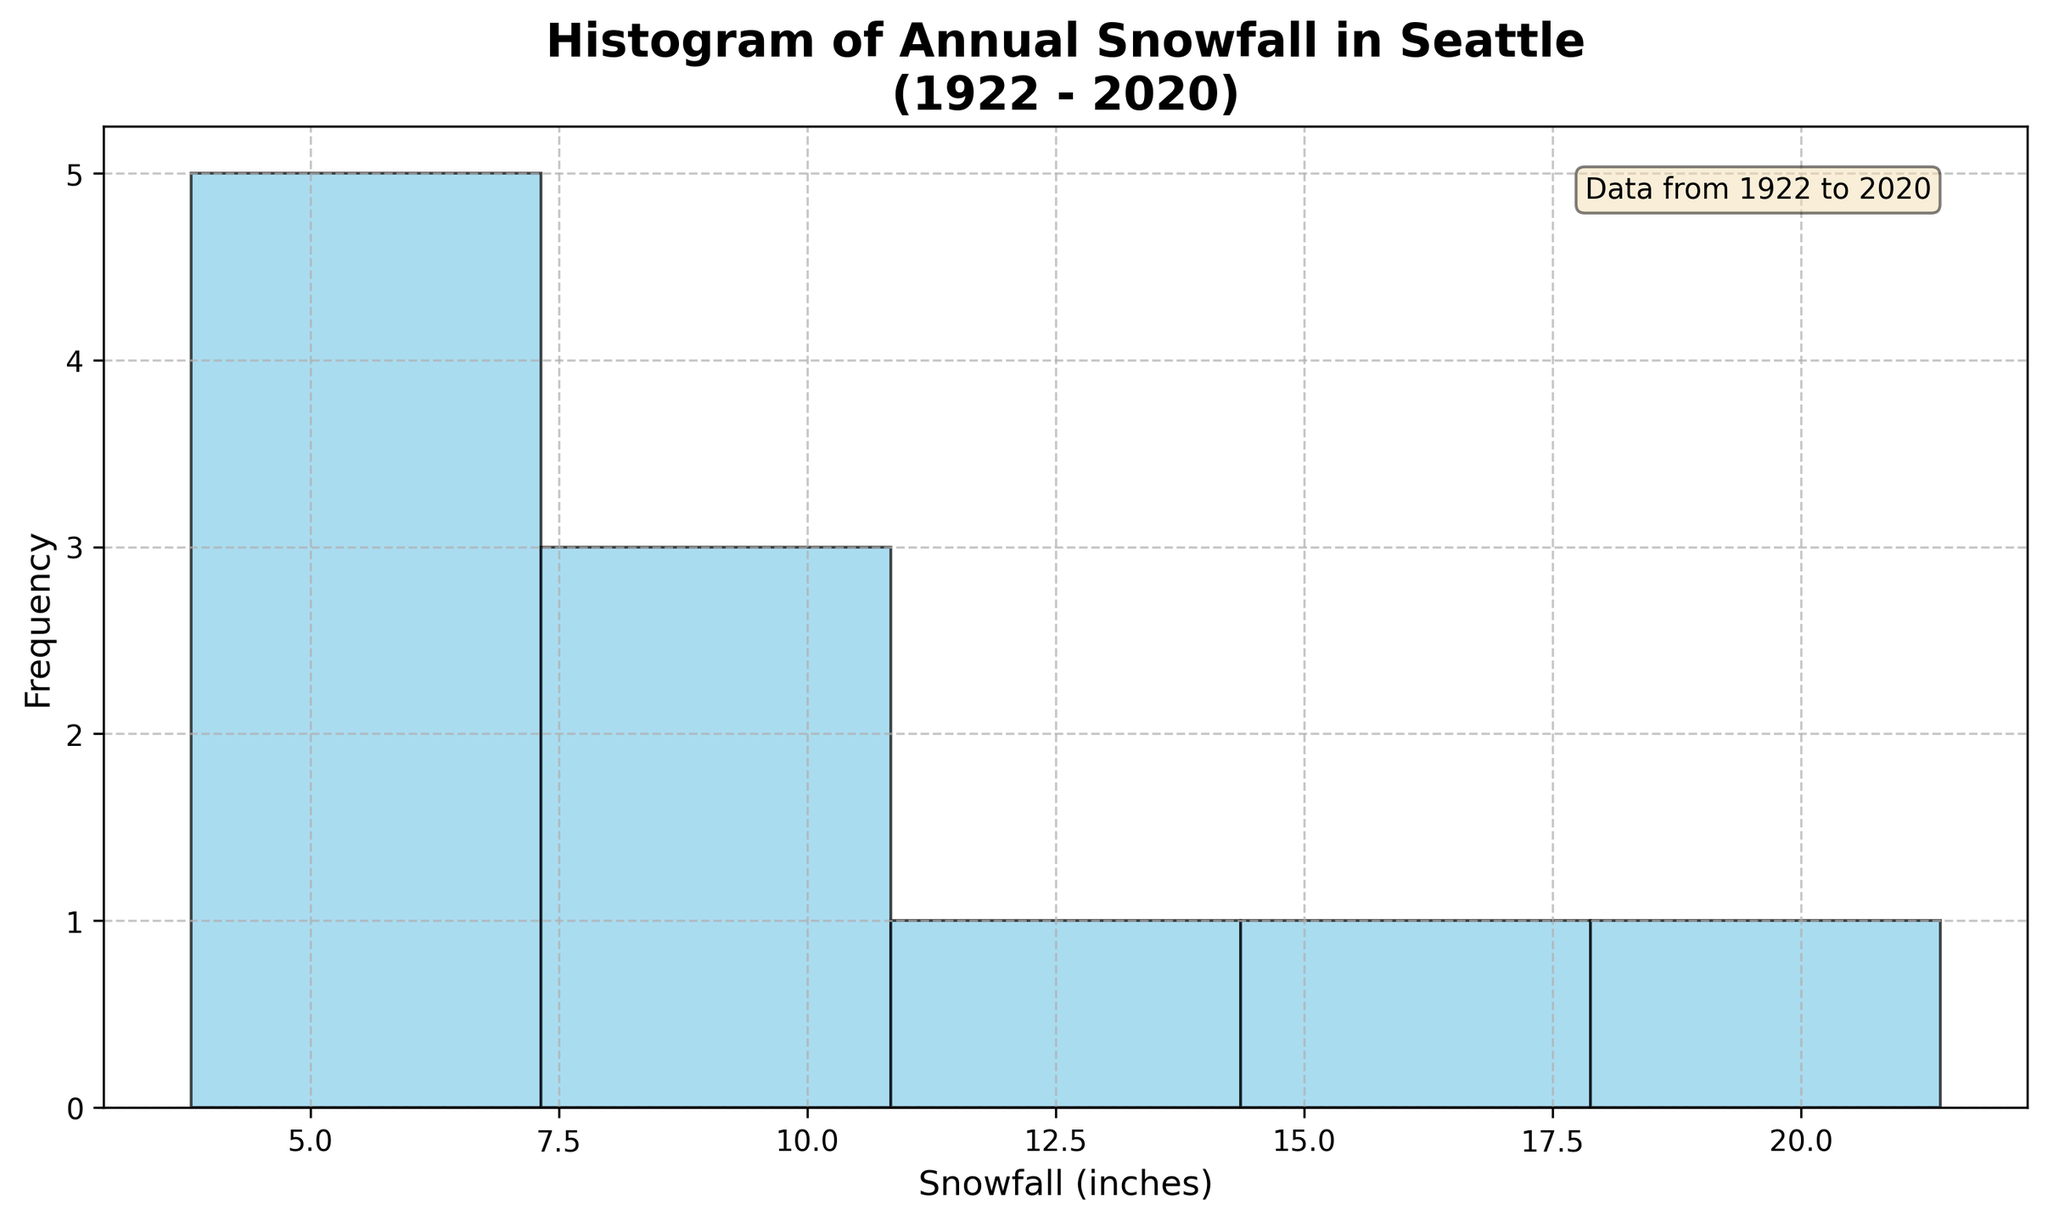What is the title of the figure? The title is written at the top of the plot. It reads: "Histogram of Annual Snowfall in Seattle (1922 - 2020)"
Answer: Histogram of Annual Snowfall in Seattle (1922 - 2020) How many bins are present in the histogram? The histogram is divided into different sections separated by vertical lines. Counting these sections shows there are 5 bins.
Answer: 5 What is the snowfall range with the highest frequency? The x-axis represents snowfall in inches, and the y-axis represents frequency. The tallest bar indicates the range with the highest frequency. Visually, the tallest bar spans between roughly 7 to 11 inches.
Answer: 7 to 11 inches Which snowfall range has the least frequency of snowfall events? The shortest bars indicate the range with the least frequency. Here, the bars at both the lower end (between 3 and 7 inches) and the higher end (between 15.7 and 21.4 inches) are the smallest.
Answer: 15.7 to 21.4 inches What is the minimum snowfall amount recorded in the provided data? Observing the bars starts from the left on the x-axis, revealing the minimum snowfall amount. The x-axis starts at about 3.8 inches, corresponding to the smallest value.
Answer: 3.8 inches What is the maximum snowfall amount recorded in the provided data? The farthest bar to the right along the x-axis represents the highest snowfall amount. The x-axis ends at 21.4 inches, which is where the last bar sits.
Answer: 21.4 inches How many years had snowfall between 5.3 and 11.8 inches? The two bins spanning from approximately 5.3 to 7.1 inches and 7.1 to 11.8 inches show their respective frequencies by the height of the bars. Counting these bars results in 2 years in the first bin and 3 years in the second. Adding these gives 2+3=5.
Answer: 5 What is the average snowfall amount from the histogram data? To find the average snowfall, sum all snowfall data (10.2, 15.7, 8.6, 21.4, 11.8, 6.9, 9.5, 5.3, 3.8, 7.1, 4.2) and then divide by the number of data points. (10.2 + 15.7 + 8.6 + 21.4 + 11.8 + 6.9 + 9.5 + 5.3 + 3.8 + 7.1 + 4.2) / 11 = 8.82.
Answer: 8.82 inches What range of snowfall values do most bins cover in the histogram? The x-axis starts at 3 inches and ends at 22 inches. The vertical bars cover the entire horizontal span, divided into 5 bins. This means each bin covers approximately (22-3)/5=3.8 inches.
Answer: About 3.8 inches per bin 